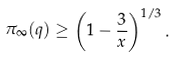<formula> <loc_0><loc_0><loc_500><loc_500>\pi _ { \infty } ( q ) \geq \left ( 1 - \frac { 3 } { x } \right ) ^ { 1 / 3 } .</formula> 